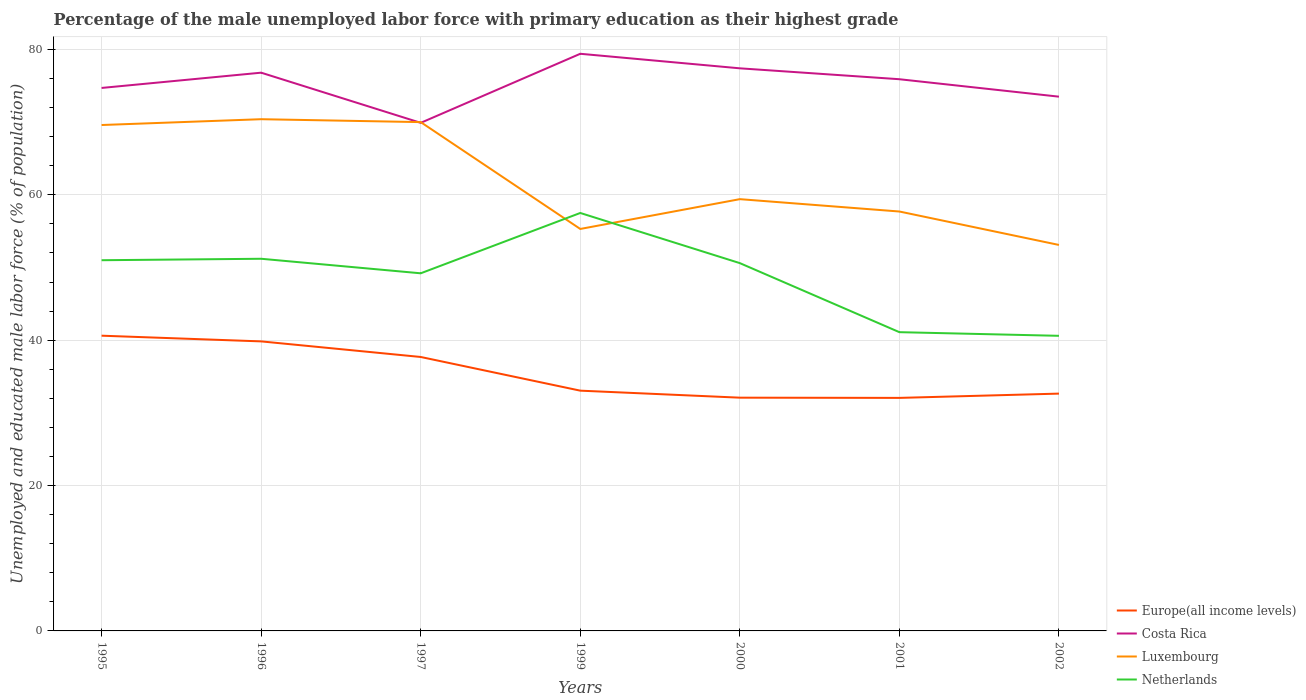How many different coloured lines are there?
Provide a short and direct response. 4. Does the line corresponding to Costa Rica intersect with the line corresponding to Luxembourg?
Give a very brief answer. Yes. Across all years, what is the maximum percentage of the unemployed male labor force with primary education in Costa Rica?
Make the answer very short. 69.9. In which year was the percentage of the unemployed male labor force with primary education in Luxembourg maximum?
Keep it short and to the point. 2002. What is the total percentage of the unemployed male labor force with primary education in Luxembourg in the graph?
Your answer should be compact. 14.3. What is the difference between the highest and the second highest percentage of the unemployed male labor force with primary education in Netherlands?
Your response must be concise. 16.9. What is the difference between the highest and the lowest percentage of the unemployed male labor force with primary education in Costa Rica?
Offer a terse response. 4. How many lines are there?
Keep it short and to the point. 4. How many years are there in the graph?
Provide a short and direct response. 7. What is the difference between two consecutive major ticks on the Y-axis?
Give a very brief answer. 20. Does the graph contain grids?
Make the answer very short. Yes. Where does the legend appear in the graph?
Ensure brevity in your answer.  Bottom right. How many legend labels are there?
Offer a very short reply. 4. How are the legend labels stacked?
Give a very brief answer. Vertical. What is the title of the graph?
Give a very brief answer. Percentage of the male unemployed labor force with primary education as their highest grade. What is the label or title of the X-axis?
Offer a terse response. Years. What is the label or title of the Y-axis?
Your response must be concise. Unemployed and educated male labor force (% of population). What is the Unemployed and educated male labor force (% of population) of Europe(all income levels) in 1995?
Give a very brief answer. 40.62. What is the Unemployed and educated male labor force (% of population) in Costa Rica in 1995?
Your answer should be very brief. 74.7. What is the Unemployed and educated male labor force (% of population) of Luxembourg in 1995?
Keep it short and to the point. 69.6. What is the Unemployed and educated male labor force (% of population) in Netherlands in 1995?
Ensure brevity in your answer.  51. What is the Unemployed and educated male labor force (% of population) of Europe(all income levels) in 1996?
Offer a very short reply. 39.83. What is the Unemployed and educated male labor force (% of population) in Costa Rica in 1996?
Offer a very short reply. 76.8. What is the Unemployed and educated male labor force (% of population) of Luxembourg in 1996?
Offer a terse response. 70.4. What is the Unemployed and educated male labor force (% of population) in Netherlands in 1996?
Offer a very short reply. 51.2. What is the Unemployed and educated male labor force (% of population) in Europe(all income levels) in 1997?
Keep it short and to the point. 37.69. What is the Unemployed and educated male labor force (% of population) in Costa Rica in 1997?
Your answer should be compact. 69.9. What is the Unemployed and educated male labor force (% of population) of Netherlands in 1997?
Your answer should be very brief. 49.2. What is the Unemployed and educated male labor force (% of population) of Europe(all income levels) in 1999?
Provide a succinct answer. 33.05. What is the Unemployed and educated male labor force (% of population) of Costa Rica in 1999?
Keep it short and to the point. 79.4. What is the Unemployed and educated male labor force (% of population) in Luxembourg in 1999?
Make the answer very short. 55.3. What is the Unemployed and educated male labor force (% of population) of Netherlands in 1999?
Make the answer very short. 57.5. What is the Unemployed and educated male labor force (% of population) of Europe(all income levels) in 2000?
Offer a very short reply. 32.09. What is the Unemployed and educated male labor force (% of population) in Costa Rica in 2000?
Ensure brevity in your answer.  77.4. What is the Unemployed and educated male labor force (% of population) in Luxembourg in 2000?
Ensure brevity in your answer.  59.4. What is the Unemployed and educated male labor force (% of population) in Netherlands in 2000?
Provide a short and direct response. 50.6. What is the Unemployed and educated male labor force (% of population) of Europe(all income levels) in 2001?
Provide a succinct answer. 32.06. What is the Unemployed and educated male labor force (% of population) of Costa Rica in 2001?
Provide a short and direct response. 75.9. What is the Unemployed and educated male labor force (% of population) of Luxembourg in 2001?
Offer a very short reply. 57.7. What is the Unemployed and educated male labor force (% of population) in Netherlands in 2001?
Keep it short and to the point. 41.1. What is the Unemployed and educated male labor force (% of population) of Europe(all income levels) in 2002?
Your answer should be compact. 32.65. What is the Unemployed and educated male labor force (% of population) in Costa Rica in 2002?
Offer a very short reply. 73.5. What is the Unemployed and educated male labor force (% of population) of Luxembourg in 2002?
Give a very brief answer. 53.1. What is the Unemployed and educated male labor force (% of population) of Netherlands in 2002?
Give a very brief answer. 40.6. Across all years, what is the maximum Unemployed and educated male labor force (% of population) in Europe(all income levels)?
Offer a terse response. 40.62. Across all years, what is the maximum Unemployed and educated male labor force (% of population) of Costa Rica?
Provide a succinct answer. 79.4. Across all years, what is the maximum Unemployed and educated male labor force (% of population) in Luxembourg?
Offer a very short reply. 70.4. Across all years, what is the maximum Unemployed and educated male labor force (% of population) of Netherlands?
Your answer should be very brief. 57.5. Across all years, what is the minimum Unemployed and educated male labor force (% of population) of Europe(all income levels)?
Keep it short and to the point. 32.06. Across all years, what is the minimum Unemployed and educated male labor force (% of population) of Costa Rica?
Offer a terse response. 69.9. Across all years, what is the minimum Unemployed and educated male labor force (% of population) of Luxembourg?
Your response must be concise. 53.1. Across all years, what is the minimum Unemployed and educated male labor force (% of population) in Netherlands?
Offer a very short reply. 40.6. What is the total Unemployed and educated male labor force (% of population) in Europe(all income levels) in the graph?
Your response must be concise. 247.99. What is the total Unemployed and educated male labor force (% of population) of Costa Rica in the graph?
Keep it short and to the point. 527.6. What is the total Unemployed and educated male labor force (% of population) of Luxembourg in the graph?
Your answer should be very brief. 435.5. What is the total Unemployed and educated male labor force (% of population) of Netherlands in the graph?
Your answer should be compact. 341.2. What is the difference between the Unemployed and educated male labor force (% of population) of Europe(all income levels) in 1995 and that in 1996?
Offer a very short reply. 0.78. What is the difference between the Unemployed and educated male labor force (% of population) of Costa Rica in 1995 and that in 1996?
Provide a succinct answer. -2.1. What is the difference between the Unemployed and educated male labor force (% of population) in Luxembourg in 1995 and that in 1996?
Provide a succinct answer. -0.8. What is the difference between the Unemployed and educated male labor force (% of population) in Netherlands in 1995 and that in 1996?
Keep it short and to the point. -0.2. What is the difference between the Unemployed and educated male labor force (% of population) in Europe(all income levels) in 1995 and that in 1997?
Your answer should be compact. 2.93. What is the difference between the Unemployed and educated male labor force (% of population) of Costa Rica in 1995 and that in 1997?
Make the answer very short. 4.8. What is the difference between the Unemployed and educated male labor force (% of population) of Luxembourg in 1995 and that in 1997?
Provide a succinct answer. -0.4. What is the difference between the Unemployed and educated male labor force (% of population) in Netherlands in 1995 and that in 1997?
Provide a short and direct response. 1.8. What is the difference between the Unemployed and educated male labor force (% of population) of Europe(all income levels) in 1995 and that in 1999?
Your answer should be compact. 7.56. What is the difference between the Unemployed and educated male labor force (% of population) of Costa Rica in 1995 and that in 1999?
Offer a very short reply. -4.7. What is the difference between the Unemployed and educated male labor force (% of population) in Netherlands in 1995 and that in 1999?
Ensure brevity in your answer.  -6.5. What is the difference between the Unemployed and educated male labor force (% of population) of Europe(all income levels) in 1995 and that in 2000?
Make the answer very short. 8.53. What is the difference between the Unemployed and educated male labor force (% of population) in Luxembourg in 1995 and that in 2000?
Keep it short and to the point. 10.2. What is the difference between the Unemployed and educated male labor force (% of population) in Europe(all income levels) in 1995 and that in 2001?
Offer a very short reply. 8.56. What is the difference between the Unemployed and educated male labor force (% of population) of Costa Rica in 1995 and that in 2001?
Ensure brevity in your answer.  -1.2. What is the difference between the Unemployed and educated male labor force (% of population) of Netherlands in 1995 and that in 2001?
Keep it short and to the point. 9.9. What is the difference between the Unemployed and educated male labor force (% of population) in Europe(all income levels) in 1995 and that in 2002?
Make the answer very short. 7.97. What is the difference between the Unemployed and educated male labor force (% of population) of Europe(all income levels) in 1996 and that in 1997?
Offer a very short reply. 2.14. What is the difference between the Unemployed and educated male labor force (% of population) of Luxembourg in 1996 and that in 1997?
Your answer should be compact. 0.4. What is the difference between the Unemployed and educated male labor force (% of population) in Europe(all income levels) in 1996 and that in 1999?
Ensure brevity in your answer.  6.78. What is the difference between the Unemployed and educated male labor force (% of population) of Luxembourg in 1996 and that in 1999?
Your answer should be compact. 15.1. What is the difference between the Unemployed and educated male labor force (% of population) of Europe(all income levels) in 1996 and that in 2000?
Your response must be concise. 7.74. What is the difference between the Unemployed and educated male labor force (% of population) in Costa Rica in 1996 and that in 2000?
Give a very brief answer. -0.6. What is the difference between the Unemployed and educated male labor force (% of population) in Netherlands in 1996 and that in 2000?
Make the answer very short. 0.6. What is the difference between the Unemployed and educated male labor force (% of population) of Europe(all income levels) in 1996 and that in 2001?
Provide a succinct answer. 7.77. What is the difference between the Unemployed and educated male labor force (% of population) in Europe(all income levels) in 1996 and that in 2002?
Provide a succinct answer. 7.18. What is the difference between the Unemployed and educated male labor force (% of population) in Europe(all income levels) in 1997 and that in 1999?
Your answer should be compact. 4.63. What is the difference between the Unemployed and educated male labor force (% of population) in Costa Rica in 1997 and that in 1999?
Your answer should be very brief. -9.5. What is the difference between the Unemployed and educated male labor force (% of population) of Europe(all income levels) in 1997 and that in 2000?
Keep it short and to the point. 5.6. What is the difference between the Unemployed and educated male labor force (% of population) in Luxembourg in 1997 and that in 2000?
Your answer should be very brief. 10.6. What is the difference between the Unemployed and educated male labor force (% of population) in Europe(all income levels) in 1997 and that in 2001?
Make the answer very short. 5.63. What is the difference between the Unemployed and educated male labor force (% of population) in Luxembourg in 1997 and that in 2001?
Provide a succinct answer. 12.3. What is the difference between the Unemployed and educated male labor force (% of population) of Europe(all income levels) in 1997 and that in 2002?
Ensure brevity in your answer.  5.04. What is the difference between the Unemployed and educated male labor force (% of population) of Luxembourg in 1997 and that in 2002?
Provide a succinct answer. 16.9. What is the difference between the Unemployed and educated male labor force (% of population) of Europe(all income levels) in 1999 and that in 2000?
Your answer should be very brief. 0.97. What is the difference between the Unemployed and educated male labor force (% of population) of Costa Rica in 1999 and that in 2001?
Offer a terse response. 3.5. What is the difference between the Unemployed and educated male labor force (% of population) in Netherlands in 1999 and that in 2001?
Provide a succinct answer. 16.4. What is the difference between the Unemployed and educated male labor force (% of population) of Europe(all income levels) in 1999 and that in 2002?
Your answer should be very brief. 0.41. What is the difference between the Unemployed and educated male labor force (% of population) of Netherlands in 1999 and that in 2002?
Ensure brevity in your answer.  16.9. What is the difference between the Unemployed and educated male labor force (% of population) of Europe(all income levels) in 2000 and that in 2001?
Offer a terse response. 0.03. What is the difference between the Unemployed and educated male labor force (% of population) in Luxembourg in 2000 and that in 2001?
Ensure brevity in your answer.  1.7. What is the difference between the Unemployed and educated male labor force (% of population) in Europe(all income levels) in 2000 and that in 2002?
Your answer should be compact. -0.56. What is the difference between the Unemployed and educated male labor force (% of population) in Costa Rica in 2000 and that in 2002?
Your answer should be very brief. 3.9. What is the difference between the Unemployed and educated male labor force (% of population) of Europe(all income levels) in 2001 and that in 2002?
Give a very brief answer. -0.59. What is the difference between the Unemployed and educated male labor force (% of population) of Luxembourg in 2001 and that in 2002?
Provide a succinct answer. 4.6. What is the difference between the Unemployed and educated male labor force (% of population) in Europe(all income levels) in 1995 and the Unemployed and educated male labor force (% of population) in Costa Rica in 1996?
Provide a short and direct response. -36.18. What is the difference between the Unemployed and educated male labor force (% of population) in Europe(all income levels) in 1995 and the Unemployed and educated male labor force (% of population) in Luxembourg in 1996?
Provide a short and direct response. -29.78. What is the difference between the Unemployed and educated male labor force (% of population) of Europe(all income levels) in 1995 and the Unemployed and educated male labor force (% of population) of Netherlands in 1996?
Keep it short and to the point. -10.58. What is the difference between the Unemployed and educated male labor force (% of population) in Costa Rica in 1995 and the Unemployed and educated male labor force (% of population) in Luxembourg in 1996?
Offer a very short reply. 4.3. What is the difference between the Unemployed and educated male labor force (% of population) in Luxembourg in 1995 and the Unemployed and educated male labor force (% of population) in Netherlands in 1996?
Provide a short and direct response. 18.4. What is the difference between the Unemployed and educated male labor force (% of population) of Europe(all income levels) in 1995 and the Unemployed and educated male labor force (% of population) of Costa Rica in 1997?
Make the answer very short. -29.28. What is the difference between the Unemployed and educated male labor force (% of population) of Europe(all income levels) in 1995 and the Unemployed and educated male labor force (% of population) of Luxembourg in 1997?
Ensure brevity in your answer.  -29.38. What is the difference between the Unemployed and educated male labor force (% of population) of Europe(all income levels) in 1995 and the Unemployed and educated male labor force (% of population) of Netherlands in 1997?
Your answer should be compact. -8.58. What is the difference between the Unemployed and educated male labor force (% of population) in Luxembourg in 1995 and the Unemployed and educated male labor force (% of population) in Netherlands in 1997?
Give a very brief answer. 20.4. What is the difference between the Unemployed and educated male labor force (% of population) in Europe(all income levels) in 1995 and the Unemployed and educated male labor force (% of population) in Costa Rica in 1999?
Your answer should be compact. -38.78. What is the difference between the Unemployed and educated male labor force (% of population) in Europe(all income levels) in 1995 and the Unemployed and educated male labor force (% of population) in Luxembourg in 1999?
Make the answer very short. -14.68. What is the difference between the Unemployed and educated male labor force (% of population) in Europe(all income levels) in 1995 and the Unemployed and educated male labor force (% of population) in Netherlands in 1999?
Your answer should be compact. -16.88. What is the difference between the Unemployed and educated male labor force (% of population) of Costa Rica in 1995 and the Unemployed and educated male labor force (% of population) of Luxembourg in 1999?
Keep it short and to the point. 19.4. What is the difference between the Unemployed and educated male labor force (% of population) in Costa Rica in 1995 and the Unemployed and educated male labor force (% of population) in Netherlands in 1999?
Your response must be concise. 17.2. What is the difference between the Unemployed and educated male labor force (% of population) of Europe(all income levels) in 1995 and the Unemployed and educated male labor force (% of population) of Costa Rica in 2000?
Your answer should be compact. -36.78. What is the difference between the Unemployed and educated male labor force (% of population) in Europe(all income levels) in 1995 and the Unemployed and educated male labor force (% of population) in Luxembourg in 2000?
Your answer should be compact. -18.78. What is the difference between the Unemployed and educated male labor force (% of population) in Europe(all income levels) in 1995 and the Unemployed and educated male labor force (% of population) in Netherlands in 2000?
Make the answer very short. -9.98. What is the difference between the Unemployed and educated male labor force (% of population) of Costa Rica in 1995 and the Unemployed and educated male labor force (% of population) of Netherlands in 2000?
Keep it short and to the point. 24.1. What is the difference between the Unemployed and educated male labor force (% of population) in Europe(all income levels) in 1995 and the Unemployed and educated male labor force (% of population) in Costa Rica in 2001?
Provide a succinct answer. -35.28. What is the difference between the Unemployed and educated male labor force (% of population) of Europe(all income levels) in 1995 and the Unemployed and educated male labor force (% of population) of Luxembourg in 2001?
Provide a succinct answer. -17.08. What is the difference between the Unemployed and educated male labor force (% of population) of Europe(all income levels) in 1995 and the Unemployed and educated male labor force (% of population) of Netherlands in 2001?
Provide a short and direct response. -0.48. What is the difference between the Unemployed and educated male labor force (% of population) in Costa Rica in 1995 and the Unemployed and educated male labor force (% of population) in Netherlands in 2001?
Keep it short and to the point. 33.6. What is the difference between the Unemployed and educated male labor force (% of population) of Europe(all income levels) in 1995 and the Unemployed and educated male labor force (% of population) of Costa Rica in 2002?
Your answer should be compact. -32.88. What is the difference between the Unemployed and educated male labor force (% of population) of Europe(all income levels) in 1995 and the Unemployed and educated male labor force (% of population) of Luxembourg in 2002?
Offer a very short reply. -12.48. What is the difference between the Unemployed and educated male labor force (% of population) in Europe(all income levels) in 1995 and the Unemployed and educated male labor force (% of population) in Netherlands in 2002?
Your response must be concise. 0.02. What is the difference between the Unemployed and educated male labor force (% of population) in Costa Rica in 1995 and the Unemployed and educated male labor force (% of population) in Luxembourg in 2002?
Keep it short and to the point. 21.6. What is the difference between the Unemployed and educated male labor force (% of population) in Costa Rica in 1995 and the Unemployed and educated male labor force (% of population) in Netherlands in 2002?
Give a very brief answer. 34.1. What is the difference between the Unemployed and educated male labor force (% of population) in Luxembourg in 1995 and the Unemployed and educated male labor force (% of population) in Netherlands in 2002?
Your answer should be very brief. 29. What is the difference between the Unemployed and educated male labor force (% of population) of Europe(all income levels) in 1996 and the Unemployed and educated male labor force (% of population) of Costa Rica in 1997?
Your answer should be compact. -30.07. What is the difference between the Unemployed and educated male labor force (% of population) of Europe(all income levels) in 1996 and the Unemployed and educated male labor force (% of population) of Luxembourg in 1997?
Provide a short and direct response. -30.17. What is the difference between the Unemployed and educated male labor force (% of population) in Europe(all income levels) in 1996 and the Unemployed and educated male labor force (% of population) in Netherlands in 1997?
Ensure brevity in your answer.  -9.37. What is the difference between the Unemployed and educated male labor force (% of population) of Costa Rica in 1996 and the Unemployed and educated male labor force (% of population) of Netherlands in 1997?
Offer a very short reply. 27.6. What is the difference between the Unemployed and educated male labor force (% of population) of Luxembourg in 1996 and the Unemployed and educated male labor force (% of population) of Netherlands in 1997?
Give a very brief answer. 21.2. What is the difference between the Unemployed and educated male labor force (% of population) of Europe(all income levels) in 1996 and the Unemployed and educated male labor force (% of population) of Costa Rica in 1999?
Keep it short and to the point. -39.57. What is the difference between the Unemployed and educated male labor force (% of population) in Europe(all income levels) in 1996 and the Unemployed and educated male labor force (% of population) in Luxembourg in 1999?
Your answer should be very brief. -15.47. What is the difference between the Unemployed and educated male labor force (% of population) in Europe(all income levels) in 1996 and the Unemployed and educated male labor force (% of population) in Netherlands in 1999?
Provide a succinct answer. -17.67. What is the difference between the Unemployed and educated male labor force (% of population) of Costa Rica in 1996 and the Unemployed and educated male labor force (% of population) of Luxembourg in 1999?
Offer a very short reply. 21.5. What is the difference between the Unemployed and educated male labor force (% of population) in Costa Rica in 1996 and the Unemployed and educated male labor force (% of population) in Netherlands in 1999?
Your answer should be very brief. 19.3. What is the difference between the Unemployed and educated male labor force (% of population) of Europe(all income levels) in 1996 and the Unemployed and educated male labor force (% of population) of Costa Rica in 2000?
Give a very brief answer. -37.57. What is the difference between the Unemployed and educated male labor force (% of population) in Europe(all income levels) in 1996 and the Unemployed and educated male labor force (% of population) in Luxembourg in 2000?
Keep it short and to the point. -19.57. What is the difference between the Unemployed and educated male labor force (% of population) in Europe(all income levels) in 1996 and the Unemployed and educated male labor force (% of population) in Netherlands in 2000?
Provide a short and direct response. -10.77. What is the difference between the Unemployed and educated male labor force (% of population) in Costa Rica in 1996 and the Unemployed and educated male labor force (% of population) in Luxembourg in 2000?
Your answer should be compact. 17.4. What is the difference between the Unemployed and educated male labor force (% of population) in Costa Rica in 1996 and the Unemployed and educated male labor force (% of population) in Netherlands in 2000?
Keep it short and to the point. 26.2. What is the difference between the Unemployed and educated male labor force (% of population) in Luxembourg in 1996 and the Unemployed and educated male labor force (% of population) in Netherlands in 2000?
Offer a very short reply. 19.8. What is the difference between the Unemployed and educated male labor force (% of population) of Europe(all income levels) in 1996 and the Unemployed and educated male labor force (% of population) of Costa Rica in 2001?
Offer a very short reply. -36.07. What is the difference between the Unemployed and educated male labor force (% of population) of Europe(all income levels) in 1996 and the Unemployed and educated male labor force (% of population) of Luxembourg in 2001?
Provide a succinct answer. -17.87. What is the difference between the Unemployed and educated male labor force (% of population) in Europe(all income levels) in 1996 and the Unemployed and educated male labor force (% of population) in Netherlands in 2001?
Ensure brevity in your answer.  -1.27. What is the difference between the Unemployed and educated male labor force (% of population) in Costa Rica in 1996 and the Unemployed and educated male labor force (% of population) in Netherlands in 2001?
Provide a succinct answer. 35.7. What is the difference between the Unemployed and educated male labor force (% of population) of Luxembourg in 1996 and the Unemployed and educated male labor force (% of population) of Netherlands in 2001?
Your response must be concise. 29.3. What is the difference between the Unemployed and educated male labor force (% of population) in Europe(all income levels) in 1996 and the Unemployed and educated male labor force (% of population) in Costa Rica in 2002?
Ensure brevity in your answer.  -33.67. What is the difference between the Unemployed and educated male labor force (% of population) of Europe(all income levels) in 1996 and the Unemployed and educated male labor force (% of population) of Luxembourg in 2002?
Make the answer very short. -13.27. What is the difference between the Unemployed and educated male labor force (% of population) of Europe(all income levels) in 1996 and the Unemployed and educated male labor force (% of population) of Netherlands in 2002?
Provide a succinct answer. -0.77. What is the difference between the Unemployed and educated male labor force (% of population) of Costa Rica in 1996 and the Unemployed and educated male labor force (% of population) of Luxembourg in 2002?
Offer a very short reply. 23.7. What is the difference between the Unemployed and educated male labor force (% of population) in Costa Rica in 1996 and the Unemployed and educated male labor force (% of population) in Netherlands in 2002?
Your answer should be very brief. 36.2. What is the difference between the Unemployed and educated male labor force (% of population) in Luxembourg in 1996 and the Unemployed and educated male labor force (% of population) in Netherlands in 2002?
Your answer should be very brief. 29.8. What is the difference between the Unemployed and educated male labor force (% of population) of Europe(all income levels) in 1997 and the Unemployed and educated male labor force (% of population) of Costa Rica in 1999?
Ensure brevity in your answer.  -41.71. What is the difference between the Unemployed and educated male labor force (% of population) in Europe(all income levels) in 1997 and the Unemployed and educated male labor force (% of population) in Luxembourg in 1999?
Provide a succinct answer. -17.61. What is the difference between the Unemployed and educated male labor force (% of population) of Europe(all income levels) in 1997 and the Unemployed and educated male labor force (% of population) of Netherlands in 1999?
Your answer should be compact. -19.81. What is the difference between the Unemployed and educated male labor force (% of population) of Costa Rica in 1997 and the Unemployed and educated male labor force (% of population) of Netherlands in 1999?
Provide a succinct answer. 12.4. What is the difference between the Unemployed and educated male labor force (% of population) of Europe(all income levels) in 1997 and the Unemployed and educated male labor force (% of population) of Costa Rica in 2000?
Ensure brevity in your answer.  -39.71. What is the difference between the Unemployed and educated male labor force (% of population) in Europe(all income levels) in 1997 and the Unemployed and educated male labor force (% of population) in Luxembourg in 2000?
Your answer should be very brief. -21.71. What is the difference between the Unemployed and educated male labor force (% of population) in Europe(all income levels) in 1997 and the Unemployed and educated male labor force (% of population) in Netherlands in 2000?
Your response must be concise. -12.91. What is the difference between the Unemployed and educated male labor force (% of population) of Costa Rica in 1997 and the Unemployed and educated male labor force (% of population) of Netherlands in 2000?
Your answer should be very brief. 19.3. What is the difference between the Unemployed and educated male labor force (% of population) in Luxembourg in 1997 and the Unemployed and educated male labor force (% of population) in Netherlands in 2000?
Your answer should be compact. 19.4. What is the difference between the Unemployed and educated male labor force (% of population) in Europe(all income levels) in 1997 and the Unemployed and educated male labor force (% of population) in Costa Rica in 2001?
Offer a terse response. -38.21. What is the difference between the Unemployed and educated male labor force (% of population) in Europe(all income levels) in 1997 and the Unemployed and educated male labor force (% of population) in Luxembourg in 2001?
Provide a succinct answer. -20.01. What is the difference between the Unemployed and educated male labor force (% of population) in Europe(all income levels) in 1997 and the Unemployed and educated male labor force (% of population) in Netherlands in 2001?
Your response must be concise. -3.41. What is the difference between the Unemployed and educated male labor force (% of population) in Costa Rica in 1997 and the Unemployed and educated male labor force (% of population) in Netherlands in 2001?
Offer a very short reply. 28.8. What is the difference between the Unemployed and educated male labor force (% of population) in Luxembourg in 1997 and the Unemployed and educated male labor force (% of population) in Netherlands in 2001?
Give a very brief answer. 28.9. What is the difference between the Unemployed and educated male labor force (% of population) in Europe(all income levels) in 1997 and the Unemployed and educated male labor force (% of population) in Costa Rica in 2002?
Keep it short and to the point. -35.81. What is the difference between the Unemployed and educated male labor force (% of population) of Europe(all income levels) in 1997 and the Unemployed and educated male labor force (% of population) of Luxembourg in 2002?
Your response must be concise. -15.41. What is the difference between the Unemployed and educated male labor force (% of population) in Europe(all income levels) in 1997 and the Unemployed and educated male labor force (% of population) in Netherlands in 2002?
Ensure brevity in your answer.  -2.91. What is the difference between the Unemployed and educated male labor force (% of population) of Costa Rica in 1997 and the Unemployed and educated male labor force (% of population) of Netherlands in 2002?
Offer a terse response. 29.3. What is the difference between the Unemployed and educated male labor force (% of population) of Luxembourg in 1997 and the Unemployed and educated male labor force (% of population) of Netherlands in 2002?
Give a very brief answer. 29.4. What is the difference between the Unemployed and educated male labor force (% of population) of Europe(all income levels) in 1999 and the Unemployed and educated male labor force (% of population) of Costa Rica in 2000?
Your answer should be compact. -44.35. What is the difference between the Unemployed and educated male labor force (% of population) in Europe(all income levels) in 1999 and the Unemployed and educated male labor force (% of population) in Luxembourg in 2000?
Keep it short and to the point. -26.35. What is the difference between the Unemployed and educated male labor force (% of population) in Europe(all income levels) in 1999 and the Unemployed and educated male labor force (% of population) in Netherlands in 2000?
Give a very brief answer. -17.55. What is the difference between the Unemployed and educated male labor force (% of population) of Costa Rica in 1999 and the Unemployed and educated male labor force (% of population) of Luxembourg in 2000?
Offer a very short reply. 20. What is the difference between the Unemployed and educated male labor force (% of population) of Costa Rica in 1999 and the Unemployed and educated male labor force (% of population) of Netherlands in 2000?
Give a very brief answer. 28.8. What is the difference between the Unemployed and educated male labor force (% of population) of Europe(all income levels) in 1999 and the Unemployed and educated male labor force (% of population) of Costa Rica in 2001?
Provide a short and direct response. -42.85. What is the difference between the Unemployed and educated male labor force (% of population) of Europe(all income levels) in 1999 and the Unemployed and educated male labor force (% of population) of Luxembourg in 2001?
Offer a terse response. -24.65. What is the difference between the Unemployed and educated male labor force (% of population) in Europe(all income levels) in 1999 and the Unemployed and educated male labor force (% of population) in Netherlands in 2001?
Offer a terse response. -8.05. What is the difference between the Unemployed and educated male labor force (% of population) in Costa Rica in 1999 and the Unemployed and educated male labor force (% of population) in Luxembourg in 2001?
Offer a very short reply. 21.7. What is the difference between the Unemployed and educated male labor force (% of population) of Costa Rica in 1999 and the Unemployed and educated male labor force (% of population) of Netherlands in 2001?
Offer a terse response. 38.3. What is the difference between the Unemployed and educated male labor force (% of population) in Europe(all income levels) in 1999 and the Unemployed and educated male labor force (% of population) in Costa Rica in 2002?
Ensure brevity in your answer.  -40.45. What is the difference between the Unemployed and educated male labor force (% of population) in Europe(all income levels) in 1999 and the Unemployed and educated male labor force (% of population) in Luxembourg in 2002?
Keep it short and to the point. -20.05. What is the difference between the Unemployed and educated male labor force (% of population) in Europe(all income levels) in 1999 and the Unemployed and educated male labor force (% of population) in Netherlands in 2002?
Make the answer very short. -7.55. What is the difference between the Unemployed and educated male labor force (% of population) in Costa Rica in 1999 and the Unemployed and educated male labor force (% of population) in Luxembourg in 2002?
Give a very brief answer. 26.3. What is the difference between the Unemployed and educated male labor force (% of population) of Costa Rica in 1999 and the Unemployed and educated male labor force (% of population) of Netherlands in 2002?
Offer a terse response. 38.8. What is the difference between the Unemployed and educated male labor force (% of population) in Luxembourg in 1999 and the Unemployed and educated male labor force (% of population) in Netherlands in 2002?
Provide a short and direct response. 14.7. What is the difference between the Unemployed and educated male labor force (% of population) in Europe(all income levels) in 2000 and the Unemployed and educated male labor force (% of population) in Costa Rica in 2001?
Make the answer very short. -43.81. What is the difference between the Unemployed and educated male labor force (% of population) of Europe(all income levels) in 2000 and the Unemployed and educated male labor force (% of population) of Luxembourg in 2001?
Offer a terse response. -25.61. What is the difference between the Unemployed and educated male labor force (% of population) in Europe(all income levels) in 2000 and the Unemployed and educated male labor force (% of population) in Netherlands in 2001?
Your answer should be compact. -9.01. What is the difference between the Unemployed and educated male labor force (% of population) in Costa Rica in 2000 and the Unemployed and educated male labor force (% of population) in Luxembourg in 2001?
Give a very brief answer. 19.7. What is the difference between the Unemployed and educated male labor force (% of population) of Costa Rica in 2000 and the Unemployed and educated male labor force (% of population) of Netherlands in 2001?
Your answer should be compact. 36.3. What is the difference between the Unemployed and educated male labor force (% of population) of Luxembourg in 2000 and the Unemployed and educated male labor force (% of population) of Netherlands in 2001?
Give a very brief answer. 18.3. What is the difference between the Unemployed and educated male labor force (% of population) in Europe(all income levels) in 2000 and the Unemployed and educated male labor force (% of population) in Costa Rica in 2002?
Make the answer very short. -41.41. What is the difference between the Unemployed and educated male labor force (% of population) in Europe(all income levels) in 2000 and the Unemployed and educated male labor force (% of population) in Luxembourg in 2002?
Make the answer very short. -21.01. What is the difference between the Unemployed and educated male labor force (% of population) in Europe(all income levels) in 2000 and the Unemployed and educated male labor force (% of population) in Netherlands in 2002?
Provide a succinct answer. -8.51. What is the difference between the Unemployed and educated male labor force (% of population) of Costa Rica in 2000 and the Unemployed and educated male labor force (% of population) of Luxembourg in 2002?
Ensure brevity in your answer.  24.3. What is the difference between the Unemployed and educated male labor force (% of population) in Costa Rica in 2000 and the Unemployed and educated male labor force (% of population) in Netherlands in 2002?
Your answer should be very brief. 36.8. What is the difference between the Unemployed and educated male labor force (% of population) in Luxembourg in 2000 and the Unemployed and educated male labor force (% of population) in Netherlands in 2002?
Your answer should be compact. 18.8. What is the difference between the Unemployed and educated male labor force (% of population) of Europe(all income levels) in 2001 and the Unemployed and educated male labor force (% of population) of Costa Rica in 2002?
Make the answer very short. -41.44. What is the difference between the Unemployed and educated male labor force (% of population) in Europe(all income levels) in 2001 and the Unemployed and educated male labor force (% of population) in Luxembourg in 2002?
Ensure brevity in your answer.  -21.04. What is the difference between the Unemployed and educated male labor force (% of population) in Europe(all income levels) in 2001 and the Unemployed and educated male labor force (% of population) in Netherlands in 2002?
Your response must be concise. -8.54. What is the difference between the Unemployed and educated male labor force (% of population) in Costa Rica in 2001 and the Unemployed and educated male labor force (% of population) in Luxembourg in 2002?
Keep it short and to the point. 22.8. What is the difference between the Unemployed and educated male labor force (% of population) of Costa Rica in 2001 and the Unemployed and educated male labor force (% of population) of Netherlands in 2002?
Offer a very short reply. 35.3. What is the difference between the Unemployed and educated male labor force (% of population) of Luxembourg in 2001 and the Unemployed and educated male labor force (% of population) of Netherlands in 2002?
Offer a very short reply. 17.1. What is the average Unemployed and educated male labor force (% of population) in Europe(all income levels) per year?
Provide a succinct answer. 35.43. What is the average Unemployed and educated male labor force (% of population) in Costa Rica per year?
Offer a very short reply. 75.37. What is the average Unemployed and educated male labor force (% of population) in Luxembourg per year?
Your response must be concise. 62.21. What is the average Unemployed and educated male labor force (% of population) of Netherlands per year?
Your answer should be very brief. 48.74. In the year 1995, what is the difference between the Unemployed and educated male labor force (% of population) of Europe(all income levels) and Unemployed and educated male labor force (% of population) of Costa Rica?
Provide a short and direct response. -34.08. In the year 1995, what is the difference between the Unemployed and educated male labor force (% of population) in Europe(all income levels) and Unemployed and educated male labor force (% of population) in Luxembourg?
Your answer should be compact. -28.98. In the year 1995, what is the difference between the Unemployed and educated male labor force (% of population) in Europe(all income levels) and Unemployed and educated male labor force (% of population) in Netherlands?
Your answer should be very brief. -10.38. In the year 1995, what is the difference between the Unemployed and educated male labor force (% of population) in Costa Rica and Unemployed and educated male labor force (% of population) in Luxembourg?
Give a very brief answer. 5.1. In the year 1995, what is the difference between the Unemployed and educated male labor force (% of population) in Costa Rica and Unemployed and educated male labor force (% of population) in Netherlands?
Give a very brief answer. 23.7. In the year 1996, what is the difference between the Unemployed and educated male labor force (% of population) of Europe(all income levels) and Unemployed and educated male labor force (% of population) of Costa Rica?
Offer a very short reply. -36.97. In the year 1996, what is the difference between the Unemployed and educated male labor force (% of population) of Europe(all income levels) and Unemployed and educated male labor force (% of population) of Luxembourg?
Ensure brevity in your answer.  -30.57. In the year 1996, what is the difference between the Unemployed and educated male labor force (% of population) of Europe(all income levels) and Unemployed and educated male labor force (% of population) of Netherlands?
Give a very brief answer. -11.37. In the year 1996, what is the difference between the Unemployed and educated male labor force (% of population) in Costa Rica and Unemployed and educated male labor force (% of population) in Netherlands?
Your answer should be very brief. 25.6. In the year 1996, what is the difference between the Unemployed and educated male labor force (% of population) in Luxembourg and Unemployed and educated male labor force (% of population) in Netherlands?
Your answer should be compact. 19.2. In the year 1997, what is the difference between the Unemployed and educated male labor force (% of population) in Europe(all income levels) and Unemployed and educated male labor force (% of population) in Costa Rica?
Provide a short and direct response. -32.21. In the year 1997, what is the difference between the Unemployed and educated male labor force (% of population) in Europe(all income levels) and Unemployed and educated male labor force (% of population) in Luxembourg?
Offer a terse response. -32.31. In the year 1997, what is the difference between the Unemployed and educated male labor force (% of population) in Europe(all income levels) and Unemployed and educated male labor force (% of population) in Netherlands?
Provide a short and direct response. -11.51. In the year 1997, what is the difference between the Unemployed and educated male labor force (% of population) in Costa Rica and Unemployed and educated male labor force (% of population) in Luxembourg?
Ensure brevity in your answer.  -0.1. In the year 1997, what is the difference between the Unemployed and educated male labor force (% of population) in Costa Rica and Unemployed and educated male labor force (% of population) in Netherlands?
Keep it short and to the point. 20.7. In the year 1997, what is the difference between the Unemployed and educated male labor force (% of population) in Luxembourg and Unemployed and educated male labor force (% of population) in Netherlands?
Ensure brevity in your answer.  20.8. In the year 1999, what is the difference between the Unemployed and educated male labor force (% of population) of Europe(all income levels) and Unemployed and educated male labor force (% of population) of Costa Rica?
Give a very brief answer. -46.35. In the year 1999, what is the difference between the Unemployed and educated male labor force (% of population) in Europe(all income levels) and Unemployed and educated male labor force (% of population) in Luxembourg?
Offer a terse response. -22.25. In the year 1999, what is the difference between the Unemployed and educated male labor force (% of population) of Europe(all income levels) and Unemployed and educated male labor force (% of population) of Netherlands?
Offer a very short reply. -24.45. In the year 1999, what is the difference between the Unemployed and educated male labor force (% of population) in Costa Rica and Unemployed and educated male labor force (% of population) in Luxembourg?
Keep it short and to the point. 24.1. In the year 1999, what is the difference between the Unemployed and educated male labor force (% of population) of Costa Rica and Unemployed and educated male labor force (% of population) of Netherlands?
Offer a very short reply. 21.9. In the year 1999, what is the difference between the Unemployed and educated male labor force (% of population) in Luxembourg and Unemployed and educated male labor force (% of population) in Netherlands?
Provide a succinct answer. -2.2. In the year 2000, what is the difference between the Unemployed and educated male labor force (% of population) of Europe(all income levels) and Unemployed and educated male labor force (% of population) of Costa Rica?
Give a very brief answer. -45.31. In the year 2000, what is the difference between the Unemployed and educated male labor force (% of population) in Europe(all income levels) and Unemployed and educated male labor force (% of population) in Luxembourg?
Ensure brevity in your answer.  -27.31. In the year 2000, what is the difference between the Unemployed and educated male labor force (% of population) of Europe(all income levels) and Unemployed and educated male labor force (% of population) of Netherlands?
Keep it short and to the point. -18.51. In the year 2000, what is the difference between the Unemployed and educated male labor force (% of population) of Costa Rica and Unemployed and educated male labor force (% of population) of Luxembourg?
Ensure brevity in your answer.  18. In the year 2000, what is the difference between the Unemployed and educated male labor force (% of population) in Costa Rica and Unemployed and educated male labor force (% of population) in Netherlands?
Your answer should be compact. 26.8. In the year 2001, what is the difference between the Unemployed and educated male labor force (% of population) of Europe(all income levels) and Unemployed and educated male labor force (% of population) of Costa Rica?
Offer a very short reply. -43.84. In the year 2001, what is the difference between the Unemployed and educated male labor force (% of population) of Europe(all income levels) and Unemployed and educated male labor force (% of population) of Luxembourg?
Make the answer very short. -25.64. In the year 2001, what is the difference between the Unemployed and educated male labor force (% of population) of Europe(all income levels) and Unemployed and educated male labor force (% of population) of Netherlands?
Give a very brief answer. -9.04. In the year 2001, what is the difference between the Unemployed and educated male labor force (% of population) of Costa Rica and Unemployed and educated male labor force (% of population) of Netherlands?
Your answer should be compact. 34.8. In the year 2002, what is the difference between the Unemployed and educated male labor force (% of population) in Europe(all income levels) and Unemployed and educated male labor force (% of population) in Costa Rica?
Offer a terse response. -40.85. In the year 2002, what is the difference between the Unemployed and educated male labor force (% of population) of Europe(all income levels) and Unemployed and educated male labor force (% of population) of Luxembourg?
Your answer should be compact. -20.45. In the year 2002, what is the difference between the Unemployed and educated male labor force (% of population) of Europe(all income levels) and Unemployed and educated male labor force (% of population) of Netherlands?
Give a very brief answer. -7.95. In the year 2002, what is the difference between the Unemployed and educated male labor force (% of population) in Costa Rica and Unemployed and educated male labor force (% of population) in Luxembourg?
Your answer should be very brief. 20.4. In the year 2002, what is the difference between the Unemployed and educated male labor force (% of population) of Costa Rica and Unemployed and educated male labor force (% of population) of Netherlands?
Your answer should be compact. 32.9. In the year 2002, what is the difference between the Unemployed and educated male labor force (% of population) of Luxembourg and Unemployed and educated male labor force (% of population) of Netherlands?
Provide a short and direct response. 12.5. What is the ratio of the Unemployed and educated male labor force (% of population) of Europe(all income levels) in 1995 to that in 1996?
Give a very brief answer. 1.02. What is the ratio of the Unemployed and educated male labor force (% of population) of Costa Rica in 1995 to that in 1996?
Keep it short and to the point. 0.97. What is the ratio of the Unemployed and educated male labor force (% of population) in Netherlands in 1995 to that in 1996?
Offer a very short reply. 1. What is the ratio of the Unemployed and educated male labor force (% of population) in Europe(all income levels) in 1995 to that in 1997?
Ensure brevity in your answer.  1.08. What is the ratio of the Unemployed and educated male labor force (% of population) in Costa Rica in 1995 to that in 1997?
Your response must be concise. 1.07. What is the ratio of the Unemployed and educated male labor force (% of population) in Luxembourg in 1995 to that in 1997?
Provide a succinct answer. 0.99. What is the ratio of the Unemployed and educated male labor force (% of population) of Netherlands in 1995 to that in 1997?
Make the answer very short. 1.04. What is the ratio of the Unemployed and educated male labor force (% of population) in Europe(all income levels) in 1995 to that in 1999?
Your response must be concise. 1.23. What is the ratio of the Unemployed and educated male labor force (% of population) of Costa Rica in 1995 to that in 1999?
Ensure brevity in your answer.  0.94. What is the ratio of the Unemployed and educated male labor force (% of population) in Luxembourg in 1995 to that in 1999?
Give a very brief answer. 1.26. What is the ratio of the Unemployed and educated male labor force (% of population) in Netherlands in 1995 to that in 1999?
Offer a terse response. 0.89. What is the ratio of the Unemployed and educated male labor force (% of population) in Europe(all income levels) in 1995 to that in 2000?
Make the answer very short. 1.27. What is the ratio of the Unemployed and educated male labor force (% of population) in Costa Rica in 1995 to that in 2000?
Provide a short and direct response. 0.97. What is the ratio of the Unemployed and educated male labor force (% of population) of Luxembourg in 1995 to that in 2000?
Your answer should be compact. 1.17. What is the ratio of the Unemployed and educated male labor force (% of population) in Netherlands in 1995 to that in 2000?
Ensure brevity in your answer.  1.01. What is the ratio of the Unemployed and educated male labor force (% of population) in Europe(all income levels) in 1995 to that in 2001?
Ensure brevity in your answer.  1.27. What is the ratio of the Unemployed and educated male labor force (% of population) in Costa Rica in 1995 to that in 2001?
Ensure brevity in your answer.  0.98. What is the ratio of the Unemployed and educated male labor force (% of population) of Luxembourg in 1995 to that in 2001?
Offer a terse response. 1.21. What is the ratio of the Unemployed and educated male labor force (% of population) of Netherlands in 1995 to that in 2001?
Offer a terse response. 1.24. What is the ratio of the Unemployed and educated male labor force (% of population) in Europe(all income levels) in 1995 to that in 2002?
Offer a terse response. 1.24. What is the ratio of the Unemployed and educated male labor force (% of population) of Costa Rica in 1995 to that in 2002?
Make the answer very short. 1.02. What is the ratio of the Unemployed and educated male labor force (% of population) in Luxembourg in 1995 to that in 2002?
Make the answer very short. 1.31. What is the ratio of the Unemployed and educated male labor force (% of population) in Netherlands in 1995 to that in 2002?
Ensure brevity in your answer.  1.26. What is the ratio of the Unemployed and educated male labor force (% of population) in Europe(all income levels) in 1996 to that in 1997?
Your answer should be compact. 1.06. What is the ratio of the Unemployed and educated male labor force (% of population) of Costa Rica in 1996 to that in 1997?
Give a very brief answer. 1.1. What is the ratio of the Unemployed and educated male labor force (% of population) of Netherlands in 1996 to that in 1997?
Make the answer very short. 1.04. What is the ratio of the Unemployed and educated male labor force (% of population) in Europe(all income levels) in 1996 to that in 1999?
Give a very brief answer. 1.21. What is the ratio of the Unemployed and educated male labor force (% of population) in Costa Rica in 1996 to that in 1999?
Keep it short and to the point. 0.97. What is the ratio of the Unemployed and educated male labor force (% of population) of Luxembourg in 1996 to that in 1999?
Your answer should be compact. 1.27. What is the ratio of the Unemployed and educated male labor force (% of population) in Netherlands in 1996 to that in 1999?
Offer a terse response. 0.89. What is the ratio of the Unemployed and educated male labor force (% of population) of Europe(all income levels) in 1996 to that in 2000?
Your answer should be very brief. 1.24. What is the ratio of the Unemployed and educated male labor force (% of population) of Costa Rica in 1996 to that in 2000?
Your response must be concise. 0.99. What is the ratio of the Unemployed and educated male labor force (% of population) in Luxembourg in 1996 to that in 2000?
Give a very brief answer. 1.19. What is the ratio of the Unemployed and educated male labor force (% of population) of Netherlands in 1996 to that in 2000?
Your answer should be compact. 1.01. What is the ratio of the Unemployed and educated male labor force (% of population) in Europe(all income levels) in 1996 to that in 2001?
Keep it short and to the point. 1.24. What is the ratio of the Unemployed and educated male labor force (% of population) of Costa Rica in 1996 to that in 2001?
Your answer should be very brief. 1.01. What is the ratio of the Unemployed and educated male labor force (% of population) of Luxembourg in 1996 to that in 2001?
Your answer should be compact. 1.22. What is the ratio of the Unemployed and educated male labor force (% of population) in Netherlands in 1996 to that in 2001?
Your answer should be compact. 1.25. What is the ratio of the Unemployed and educated male labor force (% of population) of Europe(all income levels) in 1996 to that in 2002?
Provide a succinct answer. 1.22. What is the ratio of the Unemployed and educated male labor force (% of population) in Costa Rica in 1996 to that in 2002?
Ensure brevity in your answer.  1.04. What is the ratio of the Unemployed and educated male labor force (% of population) of Luxembourg in 1996 to that in 2002?
Your answer should be compact. 1.33. What is the ratio of the Unemployed and educated male labor force (% of population) in Netherlands in 1996 to that in 2002?
Your response must be concise. 1.26. What is the ratio of the Unemployed and educated male labor force (% of population) in Europe(all income levels) in 1997 to that in 1999?
Make the answer very short. 1.14. What is the ratio of the Unemployed and educated male labor force (% of population) in Costa Rica in 1997 to that in 1999?
Offer a terse response. 0.88. What is the ratio of the Unemployed and educated male labor force (% of population) in Luxembourg in 1997 to that in 1999?
Offer a terse response. 1.27. What is the ratio of the Unemployed and educated male labor force (% of population) of Netherlands in 1997 to that in 1999?
Your response must be concise. 0.86. What is the ratio of the Unemployed and educated male labor force (% of population) of Europe(all income levels) in 1997 to that in 2000?
Offer a terse response. 1.17. What is the ratio of the Unemployed and educated male labor force (% of population) of Costa Rica in 1997 to that in 2000?
Provide a succinct answer. 0.9. What is the ratio of the Unemployed and educated male labor force (% of population) of Luxembourg in 1997 to that in 2000?
Make the answer very short. 1.18. What is the ratio of the Unemployed and educated male labor force (% of population) of Netherlands in 1997 to that in 2000?
Offer a very short reply. 0.97. What is the ratio of the Unemployed and educated male labor force (% of population) of Europe(all income levels) in 1997 to that in 2001?
Keep it short and to the point. 1.18. What is the ratio of the Unemployed and educated male labor force (% of population) in Costa Rica in 1997 to that in 2001?
Offer a very short reply. 0.92. What is the ratio of the Unemployed and educated male labor force (% of population) in Luxembourg in 1997 to that in 2001?
Your answer should be compact. 1.21. What is the ratio of the Unemployed and educated male labor force (% of population) in Netherlands in 1997 to that in 2001?
Provide a short and direct response. 1.2. What is the ratio of the Unemployed and educated male labor force (% of population) in Europe(all income levels) in 1997 to that in 2002?
Offer a terse response. 1.15. What is the ratio of the Unemployed and educated male labor force (% of population) of Costa Rica in 1997 to that in 2002?
Your answer should be very brief. 0.95. What is the ratio of the Unemployed and educated male labor force (% of population) of Luxembourg in 1997 to that in 2002?
Your answer should be compact. 1.32. What is the ratio of the Unemployed and educated male labor force (% of population) in Netherlands in 1997 to that in 2002?
Your answer should be very brief. 1.21. What is the ratio of the Unemployed and educated male labor force (% of population) of Europe(all income levels) in 1999 to that in 2000?
Provide a succinct answer. 1.03. What is the ratio of the Unemployed and educated male labor force (% of population) in Costa Rica in 1999 to that in 2000?
Provide a short and direct response. 1.03. What is the ratio of the Unemployed and educated male labor force (% of population) of Luxembourg in 1999 to that in 2000?
Your answer should be compact. 0.93. What is the ratio of the Unemployed and educated male labor force (% of population) of Netherlands in 1999 to that in 2000?
Your answer should be very brief. 1.14. What is the ratio of the Unemployed and educated male labor force (% of population) in Europe(all income levels) in 1999 to that in 2001?
Provide a succinct answer. 1.03. What is the ratio of the Unemployed and educated male labor force (% of population) in Costa Rica in 1999 to that in 2001?
Provide a succinct answer. 1.05. What is the ratio of the Unemployed and educated male labor force (% of population) in Luxembourg in 1999 to that in 2001?
Keep it short and to the point. 0.96. What is the ratio of the Unemployed and educated male labor force (% of population) in Netherlands in 1999 to that in 2001?
Your response must be concise. 1.4. What is the ratio of the Unemployed and educated male labor force (% of population) in Europe(all income levels) in 1999 to that in 2002?
Make the answer very short. 1.01. What is the ratio of the Unemployed and educated male labor force (% of population) of Costa Rica in 1999 to that in 2002?
Provide a succinct answer. 1.08. What is the ratio of the Unemployed and educated male labor force (% of population) of Luxembourg in 1999 to that in 2002?
Keep it short and to the point. 1.04. What is the ratio of the Unemployed and educated male labor force (% of population) in Netherlands in 1999 to that in 2002?
Offer a very short reply. 1.42. What is the ratio of the Unemployed and educated male labor force (% of population) of Europe(all income levels) in 2000 to that in 2001?
Your answer should be very brief. 1. What is the ratio of the Unemployed and educated male labor force (% of population) of Costa Rica in 2000 to that in 2001?
Provide a succinct answer. 1.02. What is the ratio of the Unemployed and educated male labor force (% of population) in Luxembourg in 2000 to that in 2001?
Make the answer very short. 1.03. What is the ratio of the Unemployed and educated male labor force (% of population) in Netherlands in 2000 to that in 2001?
Provide a succinct answer. 1.23. What is the ratio of the Unemployed and educated male labor force (% of population) in Europe(all income levels) in 2000 to that in 2002?
Offer a terse response. 0.98. What is the ratio of the Unemployed and educated male labor force (% of population) in Costa Rica in 2000 to that in 2002?
Ensure brevity in your answer.  1.05. What is the ratio of the Unemployed and educated male labor force (% of population) of Luxembourg in 2000 to that in 2002?
Your answer should be compact. 1.12. What is the ratio of the Unemployed and educated male labor force (% of population) in Netherlands in 2000 to that in 2002?
Keep it short and to the point. 1.25. What is the ratio of the Unemployed and educated male labor force (% of population) in Europe(all income levels) in 2001 to that in 2002?
Your answer should be compact. 0.98. What is the ratio of the Unemployed and educated male labor force (% of population) in Costa Rica in 2001 to that in 2002?
Offer a terse response. 1.03. What is the ratio of the Unemployed and educated male labor force (% of population) of Luxembourg in 2001 to that in 2002?
Your answer should be very brief. 1.09. What is the ratio of the Unemployed and educated male labor force (% of population) in Netherlands in 2001 to that in 2002?
Your answer should be very brief. 1.01. What is the difference between the highest and the second highest Unemployed and educated male labor force (% of population) of Europe(all income levels)?
Provide a succinct answer. 0.78. What is the difference between the highest and the second highest Unemployed and educated male labor force (% of population) in Costa Rica?
Ensure brevity in your answer.  2. What is the difference between the highest and the second highest Unemployed and educated male labor force (% of population) in Luxembourg?
Offer a very short reply. 0.4. What is the difference between the highest and the lowest Unemployed and educated male labor force (% of population) in Europe(all income levels)?
Keep it short and to the point. 8.56. What is the difference between the highest and the lowest Unemployed and educated male labor force (% of population) in Costa Rica?
Keep it short and to the point. 9.5. What is the difference between the highest and the lowest Unemployed and educated male labor force (% of population) in Luxembourg?
Offer a very short reply. 17.3. 